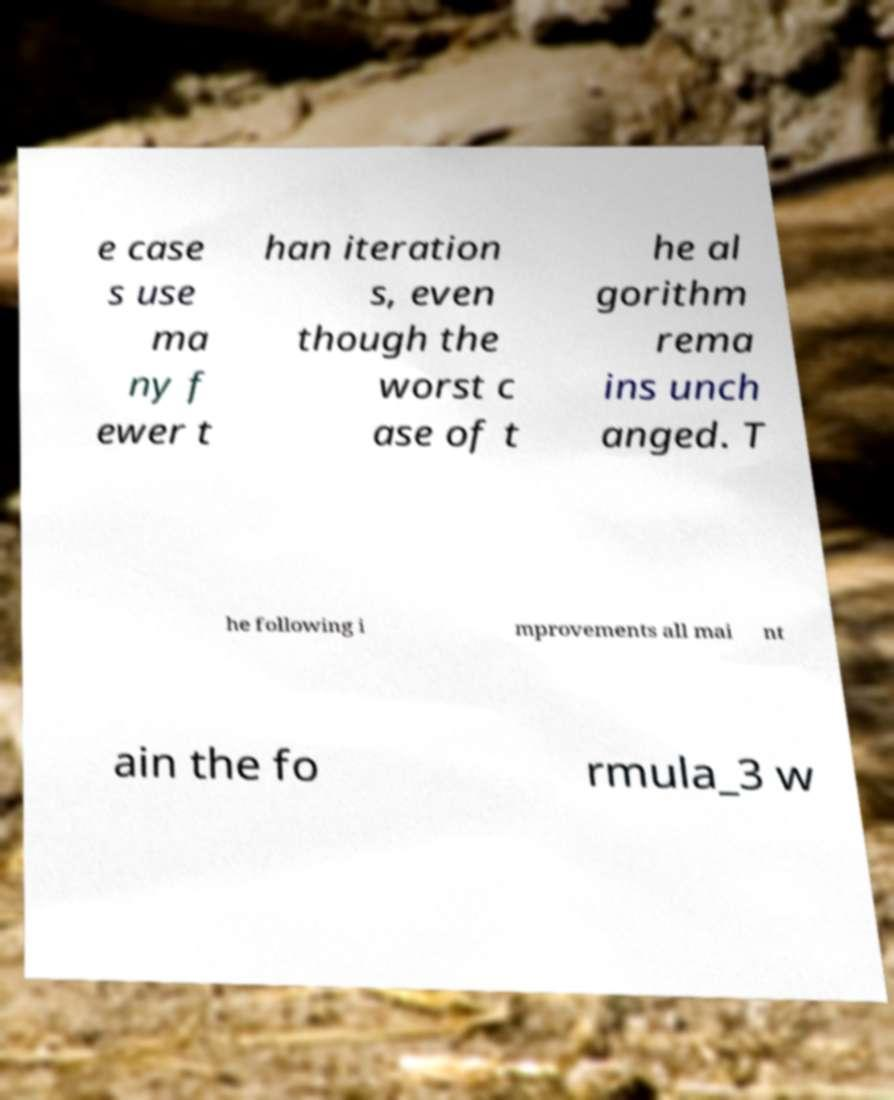Could you extract and type out the text from this image? e case s use ma ny f ewer t han iteration s, even though the worst c ase of t he al gorithm rema ins unch anged. T he following i mprovements all mai nt ain the fo rmula_3 w 